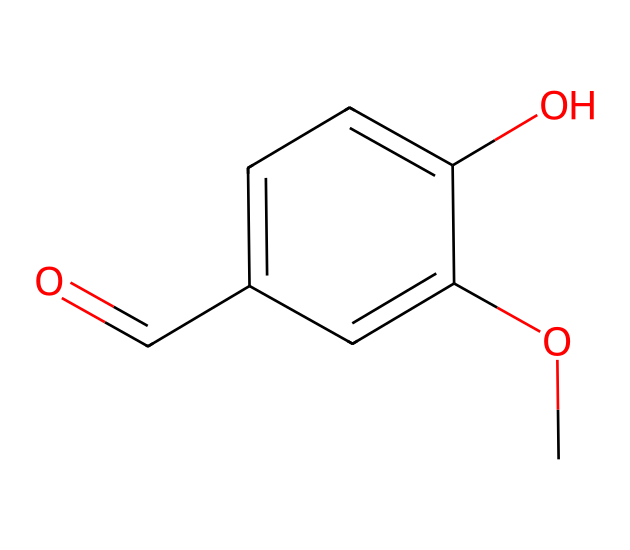What is the name of this compound? The SMILES representation corresponds to a molecule known for its flavoring properties in desserts, specifically being derived from vanilla beans; thus, the name of the compound is vanillin.
Answer: vanillin How many carbon atoms are in vanillin? By examining the structure represented in the SMILES, there are eight carbon atoms present in the compound, indicated by the 'c' and 'C' notation in the structure.
Answer: eight What is the functional group present in vanillin? The SMILES structure shows a hydroxyl group (-OH) and a carbonyl group (C=O) attached to the aromatic ring, which identifies the presence of both a phenolic (due to -OH) and an aldehyde (due to C=O) functional group.
Answer: phenolic and aldehyde How many hydrogen atoms are attached to carbon in vanillin? In the structure, counting the hydrogen atoms bonded to carbon reveals that there are eight hydrogen atoms, which can be deduced by balancing the tetravalency of carbon in the structure.
Answer: eight What is the primary reason vanillin is used in desserts? The molecular structure shows that vanillin has a sweet and pleasant aromatic profile which is highly desirable in food, particularly in Italian desserts that traditionally incorporate vanilla flavors.
Answer: aroma 